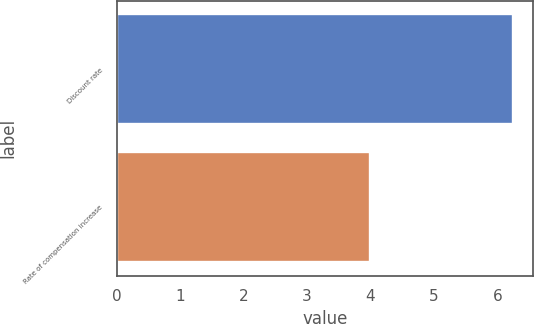<chart> <loc_0><loc_0><loc_500><loc_500><bar_chart><fcel>Discount rate<fcel>Rate of compensation increase<nl><fcel>6.25<fcel>4<nl></chart> 